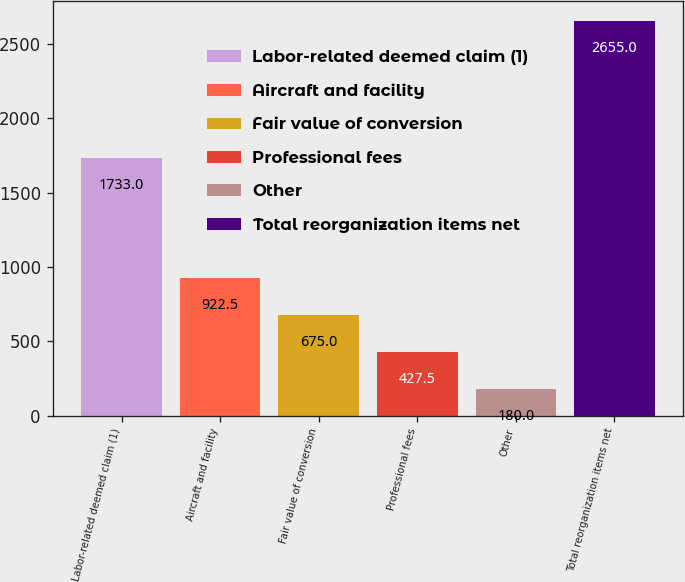<chart> <loc_0><loc_0><loc_500><loc_500><bar_chart><fcel>Labor-related deemed claim (1)<fcel>Aircraft and facility<fcel>Fair value of conversion<fcel>Professional fees<fcel>Other<fcel>Total reorganization items net<nl><fcel>1733<fcel>922.5<fcel>675<fcel>427.5<fcel>180<fcel>2655<nl></chart> 